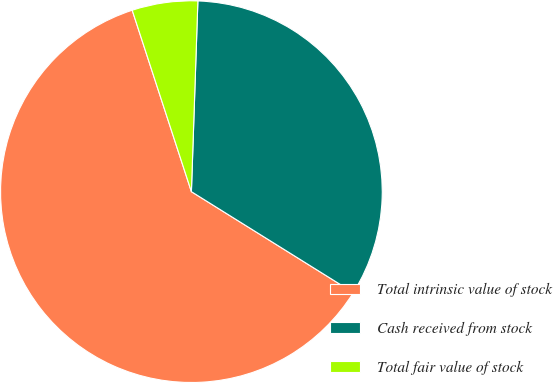<chart> <loc_0><loc_0><loc_500><loc_500><pie_chart><fcel>Total intrinsic value of stock<fcel>Cash received from stock<fcel>Total fair value of stock<nl><fcel>61.11%<fcel>33.33%<fcel>5.56%<nl></chart> 